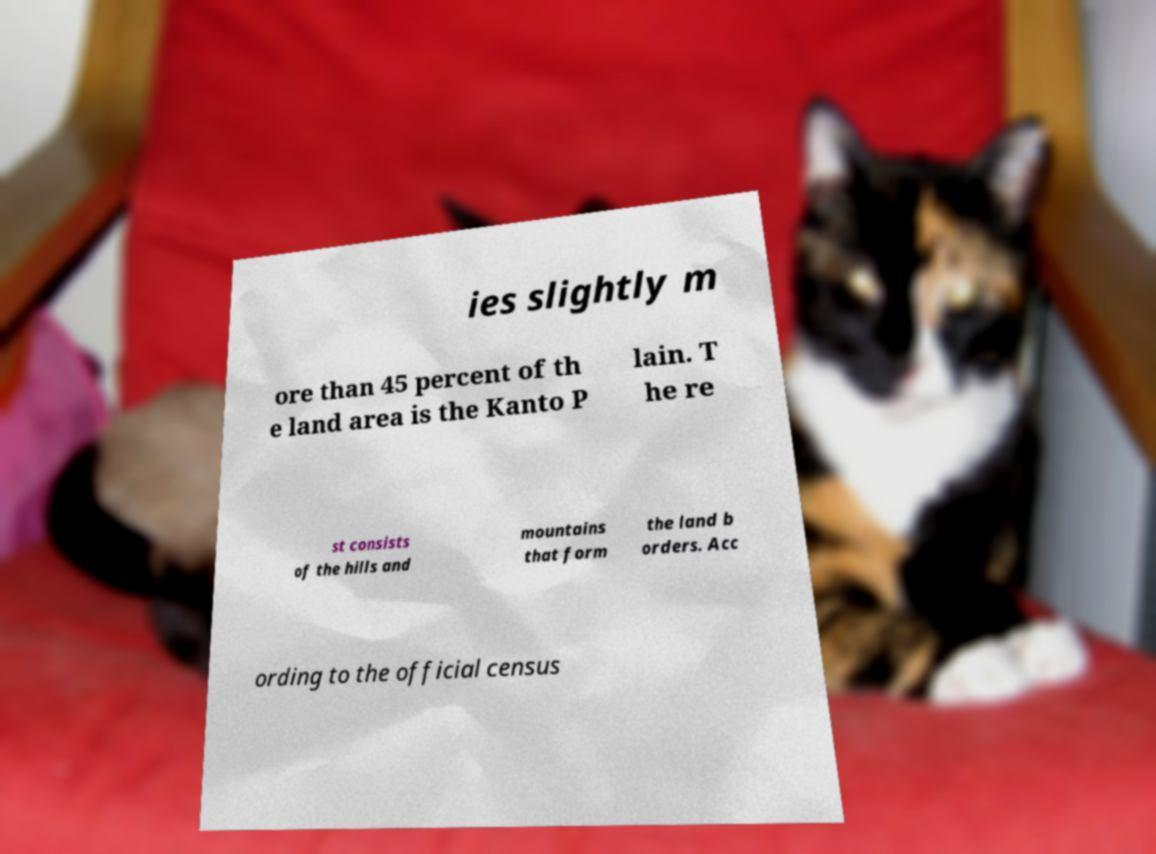Could you extract and type out the text from this image? ies slightly m ore than 45 percent of th e land area is the Kanto P lain. T he re st consists of the hills and mountains that form the land b orders. Acc ording to the official census 